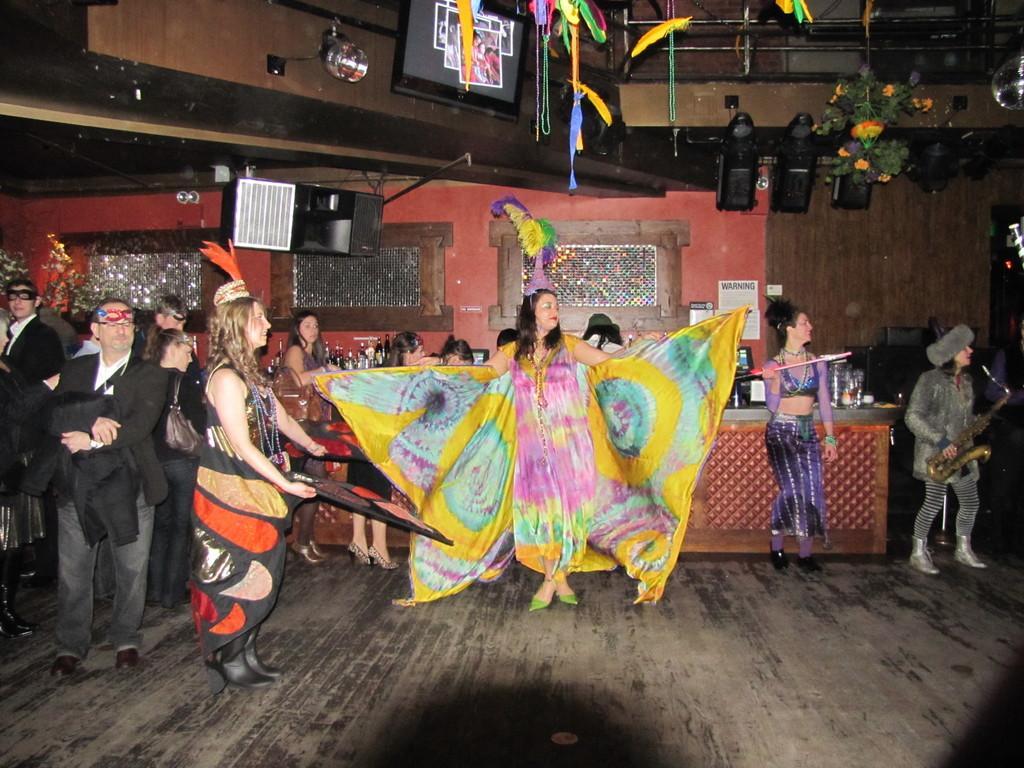How would you summarize this image in a sentence or two? In this image, we can see persons in front of the counter. There are speakers in the middle of the image. There is a screen and light at the top of the image. There are decors in the top right of the image. 